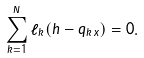Convert formula to latex. <formula><loc_0><loc_0><loc_500><loc_500>\sum _ { k = 1 } ^ { N } \ell _ { k } ( h - q _ { k \, x } ) = 0 .</formula> 